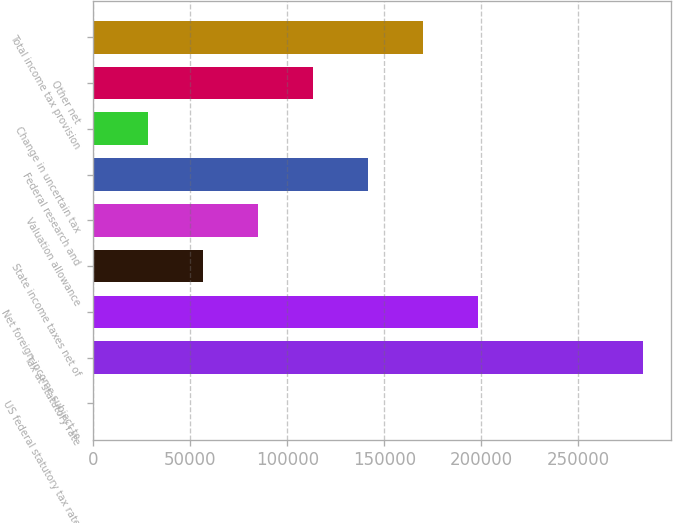Convert chart. <chart><loc_0><loc_0><loc_500><loc_500><bar_chart><fcel>US federal statutory tax rate<fcel>Tax at statutory rate<fcel>Net foreign income subject to<fcel>State income taxes net of<fcel>Valuation allowance<fcel>Federal research and<fcel>Change in uncertain tax<fcel>Other net<fcel>Total income tax provision<nl><fcel>35<fcel>283540<fcel>198488<fcel>56736<fcel>85086.5<fcel>141788<fcel>28385.5<fcel>113437<fcel>170138<nl></chart> 